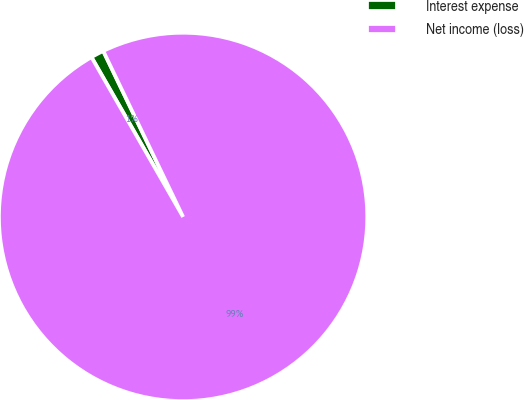Convert chart to OTSL. <chart><loc_0><loc_0><loc_500><loc_500><pie_chart><fcel>Interest expense<fcel>Net income (loss)<nl><fcel>1.15%<fcel>98.85%<nl></chart> 